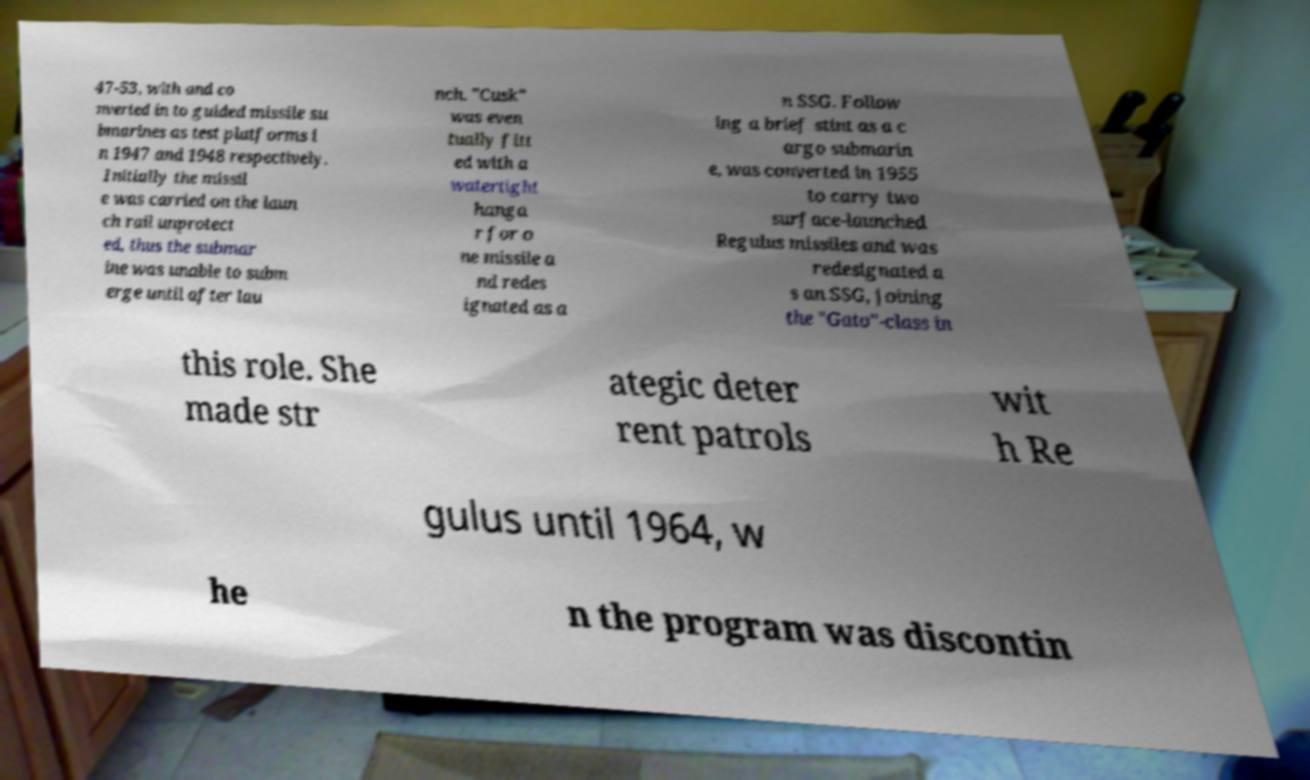Can you accurately transcribe the text from the provided image for me? 47-53, with and co nverted in to guided missile su bmarines as test platforms i n 1947 and 1948 respectively. Initially the missil e was carried on the laun ch rail unprotect ed, thus the submar ine was unable to subm erge until after lau nch. "Cusk" was even tually fitt ed with a watertight hanga r for o ne missile a nd redes ignated as a n SSG. Follow ing a brief stint as a c argo submarin e, was converted in 1955 to carry two surface-launched Regulus missiles and was redesignated a s an SSG, joining the "Gato"-class in this role. She made str ategic deter rent patrols wit h Re gulus until 1964, w he n the program was discontin 